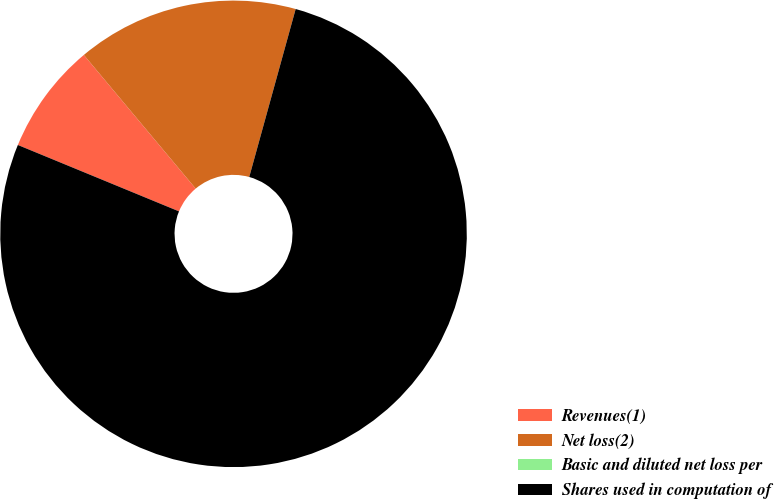Convert chart. <chart><loc_0><loc_0><loc_500><loc_500><pie_chart><fcel>Revenues(1)<fcel>Net loss(2)<fcel>Basic and diluted net loss per<fcel>Shares used in computation of<nl><fcel>7.69%<fcel>15.38%<fcel>0.0%<fcel>76.92%<nl></chart> 